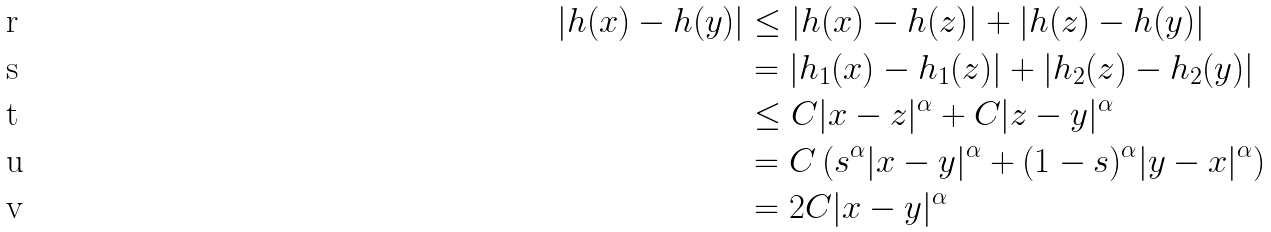<formula> <loc_0><loc_0><loc_500><loc_500>| h ( x ) - h ( y ) | & \leq | h ( x ) - h ( z ) | + | h ( z ) - h ( y ) | \\ & = | h _ { 1 } ( x ) - h _ { 1 } ( z ) | + | h _ { 2 } ( z ) - h _ { 2 } ( y ) | \\ & \leq C | x - z | ^ { \alpha } + C | z - y | ^ { \alpha } \\ & = C \left ( s ^ { \alpha } | x - y | ^ { \alpha } + ( 1 - s ) ^ { \alpha } | y - x | ^ { \alpha } \right ) \\ & = 2 C | x - y | ^ { \alpha }</formula> 